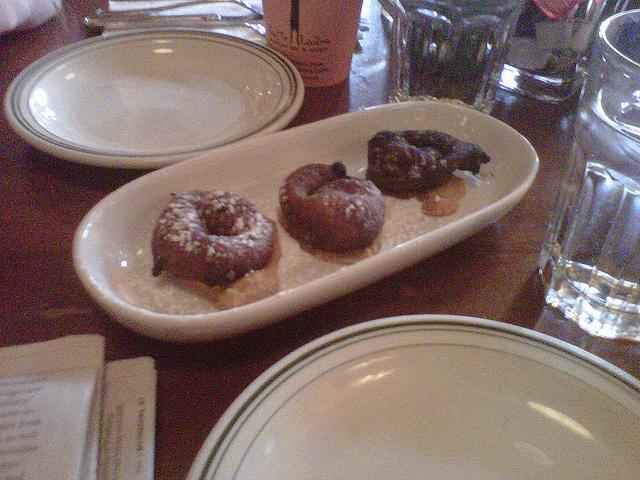What is the white bits on the food?
Short answer required. Sugar. What type of food is on the middle plate?
Give a very brief answer. Donuts. How many donuts are in this picture?
Write a very short answer. 3. Are any of the containers empty?
Answer briefly. Yes. Is the food sweet?
Short answer required. Yes. 